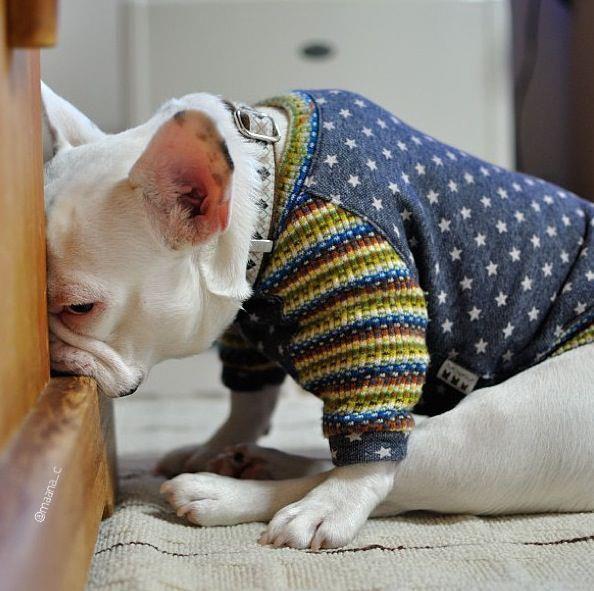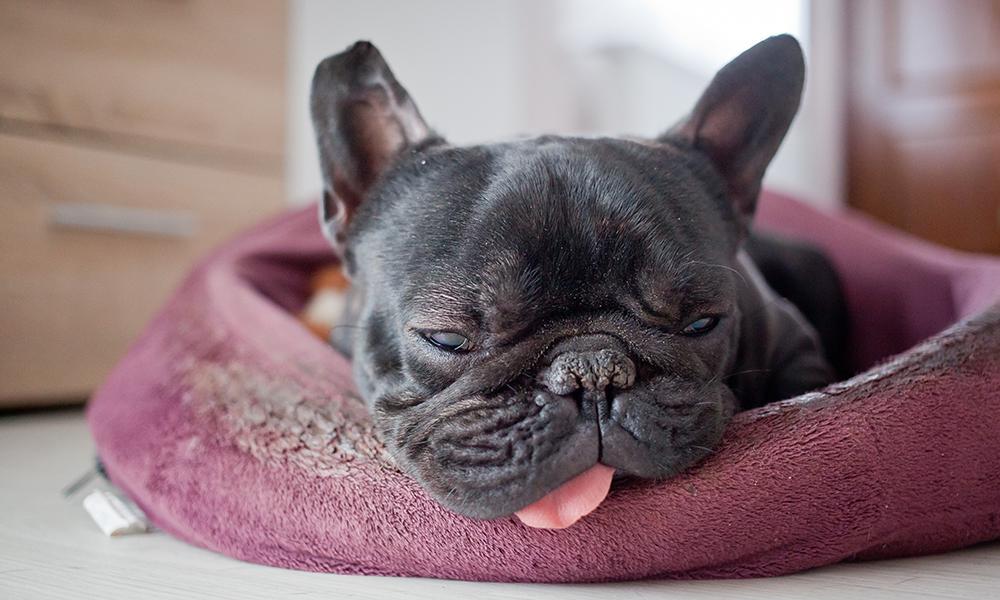The first image is the image on the left, the second image is the image on the right. For the images shown, is this caption "One dog is standing." true? Answer yes or no. No. The first image is the image on the left, the second image is the image on the right. Examine the images to the left and right. Is the description "The right image contains one dark french bulldog facing forward, the left image contains a white bulldog in the foreground, and one of the dogs pictured has its tongue out." accurate? Answer yes or no. Yes. 